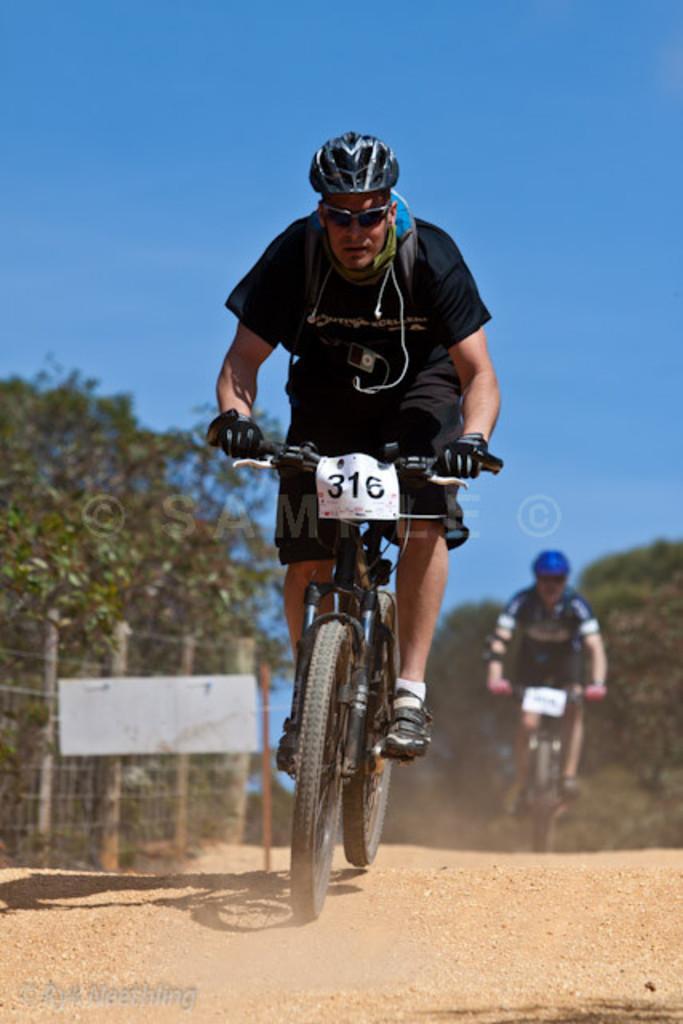Please provide a concise description of this image. In this image there is a person who is cycling on the road, Behind him there is another person who is cycling on the road. On the left side there is a fence. There are trees on either side of the road. At the top there is the sky. The man is wearing the helmet and gloves. There is a number plate to the cycle. 